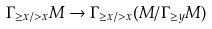<formula> <loc_0><loc_0><loc_500><loc_500>\Gamma _ { \geq x / > x } M \to \Gamma _ { \geq x / > x } ( M / \Gamma _ { \geq y } M )</formula> 